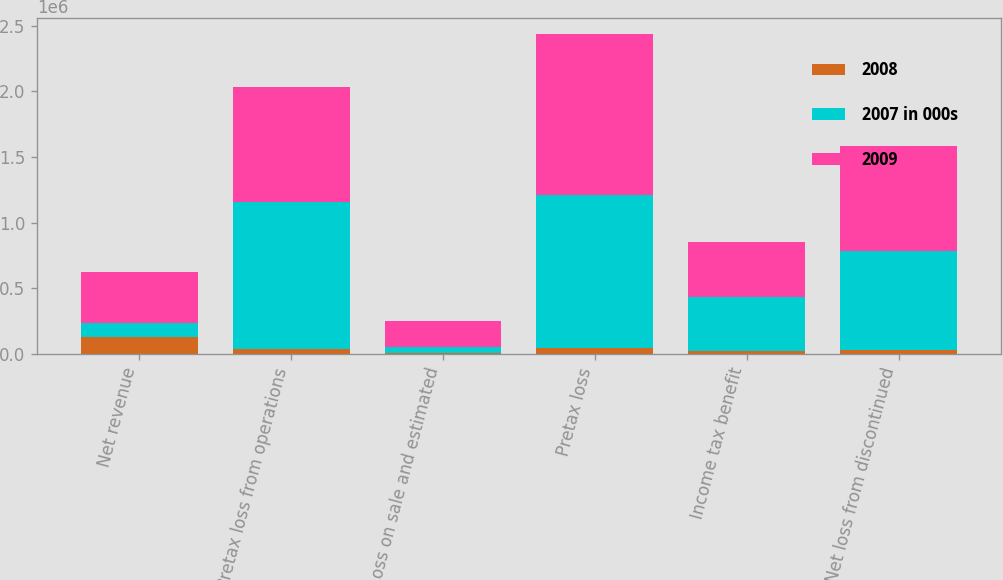Convert chart to OTSL. <chart><loc_0><loc_0><loc_500><loc_500><stacked_bar_chart><ecel><fcel>Net revenue<fcel>Pretax loss from operations<fcel>Loss on sale and estimated<fcel>Pretax loss<fcel>Income tax benefit<fcel>Net loss from discontinued<nl><fcel>2008<fcel>129863<fcel>37015<fcel>10626<fcel>47641<fcel>20259<fcel>27382<nl><fcel>2007 in 000s<fcel>105964<fcel>1.12022e+06<fcel>45510<fcel>1.16573e+06<fcel>411132<fcel>754594<nl><fcel>2009<fcel>385486<fcel>873593<fcel>193367<fcel>1.22447e+06<fcel>421358<fcel>803113<nl></chart> 